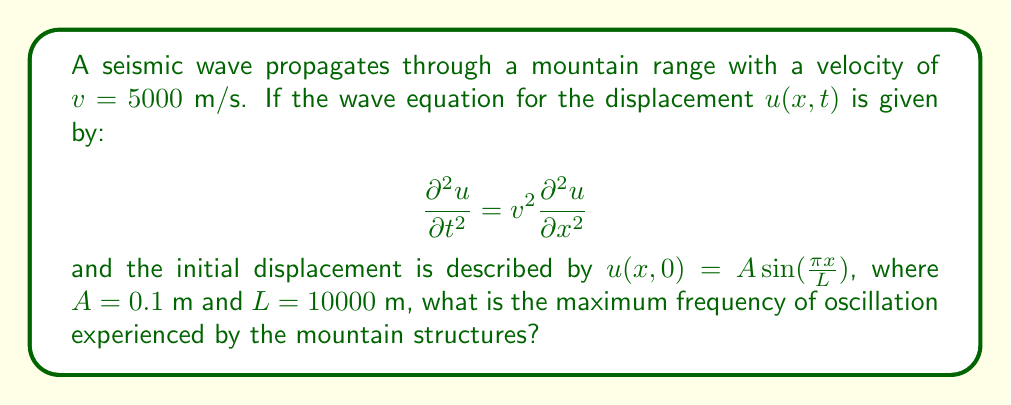Can you answer this question? To solve this problem, we'll follow these steps:

1) The general solution to the wave equation with the given initial condition is:

   $$u(x,t) = A\sin(\frac{\pi x}{L})\cos(\frac{\pi v t}{L})$$

2) The frequency of oscillation is determined by the time-dependent part of the solution:

   $$\cos(\frac{\pi v t}{L})$$

3) The angular frequency $\omega$ is the coefficient of $t$:

   $$\omega = \frac{\pi v}{L}$$

4) To convert angular frequency to regular frequency $f$, we use:

   $$f = \frac{\omega}{2\pi}$$

5) Substituting the values:

   $$f = \frac{\pi v}{2\pi L} = \frac{v}{2L}$$

6) Now, let's plug in the given values:

   $$f = \frac{5000 \text{ m/s}}{2 \cdot 10000 \text{ m}} = 0.25 \text{ Hz}$$

This is the maximum frequency of oscillation experienced by the mountain structures due to the seismic wave.
Answer: 0.25 Hz 